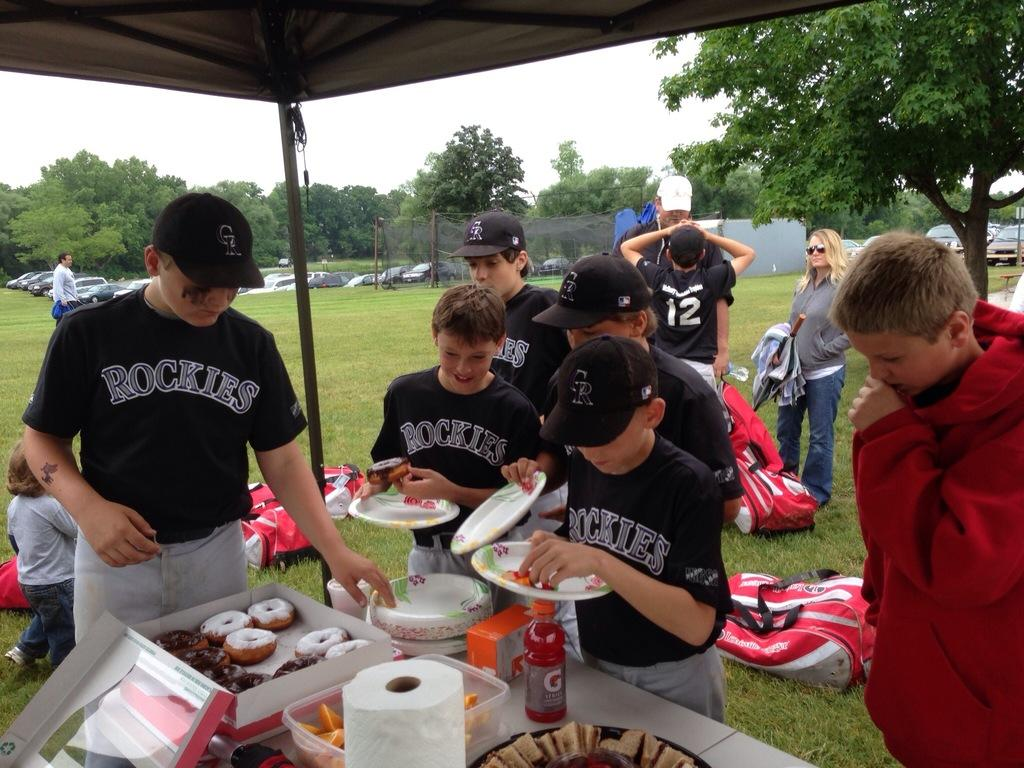<image>
Offer a succinct explanation of the picture presented. Young boys in Rockies baseball uniforms pick up donuts at a table. 